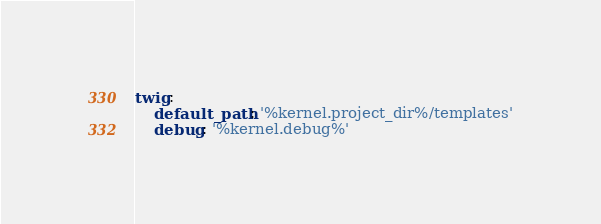<code> <loc_0><loc_0><loc_500><loc_500><_YAML_>twig:
    default_path: '%kernel.project_dir%/templates'
    debug: '%kernel.debug%'
</code> 